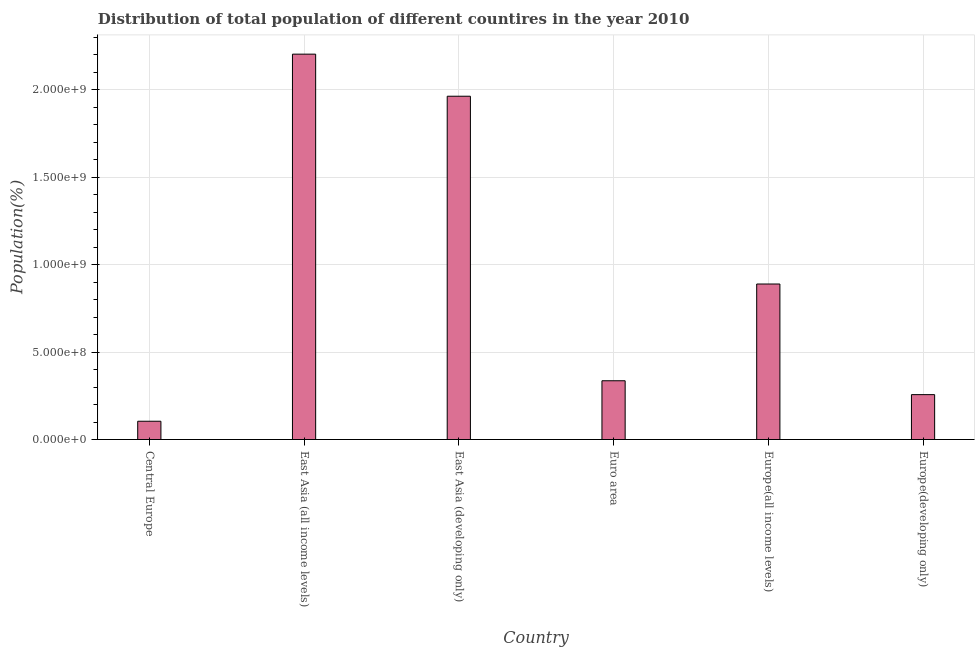Does the graph contain any zero values?
Provide a succinct answer. No. Does the graph contain grids?
Offer a terse response. Yes. What is the title of the graph?
Your answer should be very brief. Distribution of total population of different countires in the year 2010. What is the label or title of the X-axis?
Your answer should be compact. Country. What is the label or title of the Y-axis?
Keep it short and to the point. Population(%). What is the population in Europe(developing only)?
Offer a terse response. 2.57e+08. Across all countries, what is the maximum population?
Ensure brevity in your answer.  2.20e+09. Across all countries, what is the minimum population?
Give a very brief answer. 1.05e+08. In which country was the population maximum?
Your response must be concise. East Asia (all income levels). In which country was the population minimum?
Make the answer very short. Central Europe. What is the sum of the population?
Make the answer very short. 5.76e+09. What is the difference between the population in Europe(all income levels) and Europe(developing only)?
Provide a short and direct response. 6.33e+08. What is the average population per country?
Give a very brief answer. 9.59e+08. What is the median population?
Ensure brevity in your answer.  6.13e+08. In how many countries, is the population greater than 800000000 %?
Make the answer very short. 3. What is the ratio of the population in Euro area to that in Europe(developing only)?
Give a very brief answer. 1.31. Is the difference between the population in Euro area and Europe(developing only) greater than the difference between any two countries?
Your response must be concise. No. What is the difference between the highest and the second highest population?
Your answer should be compact. 2.41e+08. What is the difference between the highest and the lowest population?
Your answer should be very brief. 2.10e+09. How many bars are there?
Offer a terse response. 6. How many countries are there in the graph?
Your response must be concise. 6. What is the Population(%) of Central Europe?
Make the answer very short. 1.05e+08. What is the Population(%) in East Asia (all income levels)?
Make the answer very short. 2.20e+09. What is the Population(%) in East Asia (developing only)?
Ensure brevity in your answer.  1.96e+09. What is the Population(%) of Euro area?
Offer a terse response. 3.36e+08. What is the Population(%) in Europe(all income levels)?
Give a very brief answer. 8.90e+08. What is the Population(%) of Europe(developing only)?
Provide a succinct answer. 2.57e+08. What is the difference between the Population(%) in Central Europe and East Asia (all income levels)?
Your answer should be compact. -2.10e+09. What is the difference between the Population(%) in Central Europe and East Asia (developing only)?
Offer a terse response. -1.86e+09. What is the difference between the Population(%) in Central Europe and Euro area?
Your response must be concise. -2.32e+08. What is the difference between the Population(%) in Central Europe and Europe(all income levels)?
Your response must be concise. -7.85e+08. What is the difference between the Population(%) in Central Europe and Europe(developing only)?
Keep it short and to the point. -1.52e+08. What is the difference between the Population(%) in East Asia (all income levels) and East Asia (developing only)?
Offer a very short reply. 2.41e+08. What is the difference between the Population(%) in East Asia (all income levels) and Euro area?
Provide a short and direct response. 1.87e+09. What is the difference between the Population(%) in East Asia (all income levels) and Europe(all income levels)?
Provide a succinct answer. 1.31e+09. What is the difference between the Population(%) in East Asia (all income levels) and Europe(developing only)?
Offer a very short reply. 1.95e+09. What is the difference between the Population(%) in East Asia (developing only) and Euro area?
Keep it short and to the point. 1.63e+09. What is the difference between the Population(%) in East Asia (developing only) and Europe(all income levels)?
Provide a succinct answer. 1.07e+09. What is the difference between the Population(%) in East Asia (developing only) and Europe(developing only)?
Keep it short and to the point. 1.71e+09. What is the difference between the Population(%) in Euro area and Europe(all income levels)?
Ensure brevity in your answer.  -5.53e+08. What is the difference between the Population(%) in Euro area and Europe(developing only)?
Keep it short and to the point. 7.94e+07. What is the difference between the Population(%) in Europe(all income levels) and Europe(developing only)?
Offer a very short reply. 6.33e+08. What is the ratio of the Population(%) in Central Europe to that in East Asia (all income levels)?
Offer a terse response. 0.05. What is the ratio of the Population(%) in Central Europe to that in East Asia (developing only)?
Your answer should be very brief. 0.05. What is the ratio of the Population(%) in Central Europe to that in Euro area?
Offer a very short reply. 0.31. What is the ratio of the Population(%) in Central Europe to that in Europe(all income levels)?
Your answer should be very brief. 0.12. What is the ratio of the Population(%) in Central Europe to that in Europe(developing only)?
Keep it short and to the point. 0.41. What is the ratio of the Population(%) in East Asia (all income levels) to that in East Asia (developing only)?
Make the answer very short. 1.12. What is the ratio of the Population(%) in East Asia (all income levels) to that in Euro area?
Offer a terse response. 6.56. What is the ratio of the Population(%) in East Asia (all income levels) to that in Europe(all income levels)?
Provide a succinct answer. 2.48. What is the ratio of the Population(%) in East Asia (all income levels) to that in Europe(developing only)?
Your response must be concise. 8.59. What is the ratio of the Population(%) in East Asia (developing only) to that in Euro area?
Keep it short and to the point. 5.84. What is the ratio of the Population(%) in East Asia (developing only) to that in Europe(all income levels)?
Offer a terse response. 2.21. What is the ratio of the Population(%) in East Asia (developing only) to that in Europe(developing only)?
Your answer should be very brief. 7.65. What is the ratio of the Population(%) in Euro area to that in Europe(all income levels)?
Your answer should be very brief. 0.38. What is the ratio of the Population(%) in Euro area to that in Europe(developing only)?
Make the answer very short. 1.31. What is the ratio of the Population(%) in Europe(all income levels) to that in Europe(developing only)?
Provide a succinct answer. 3.46. 